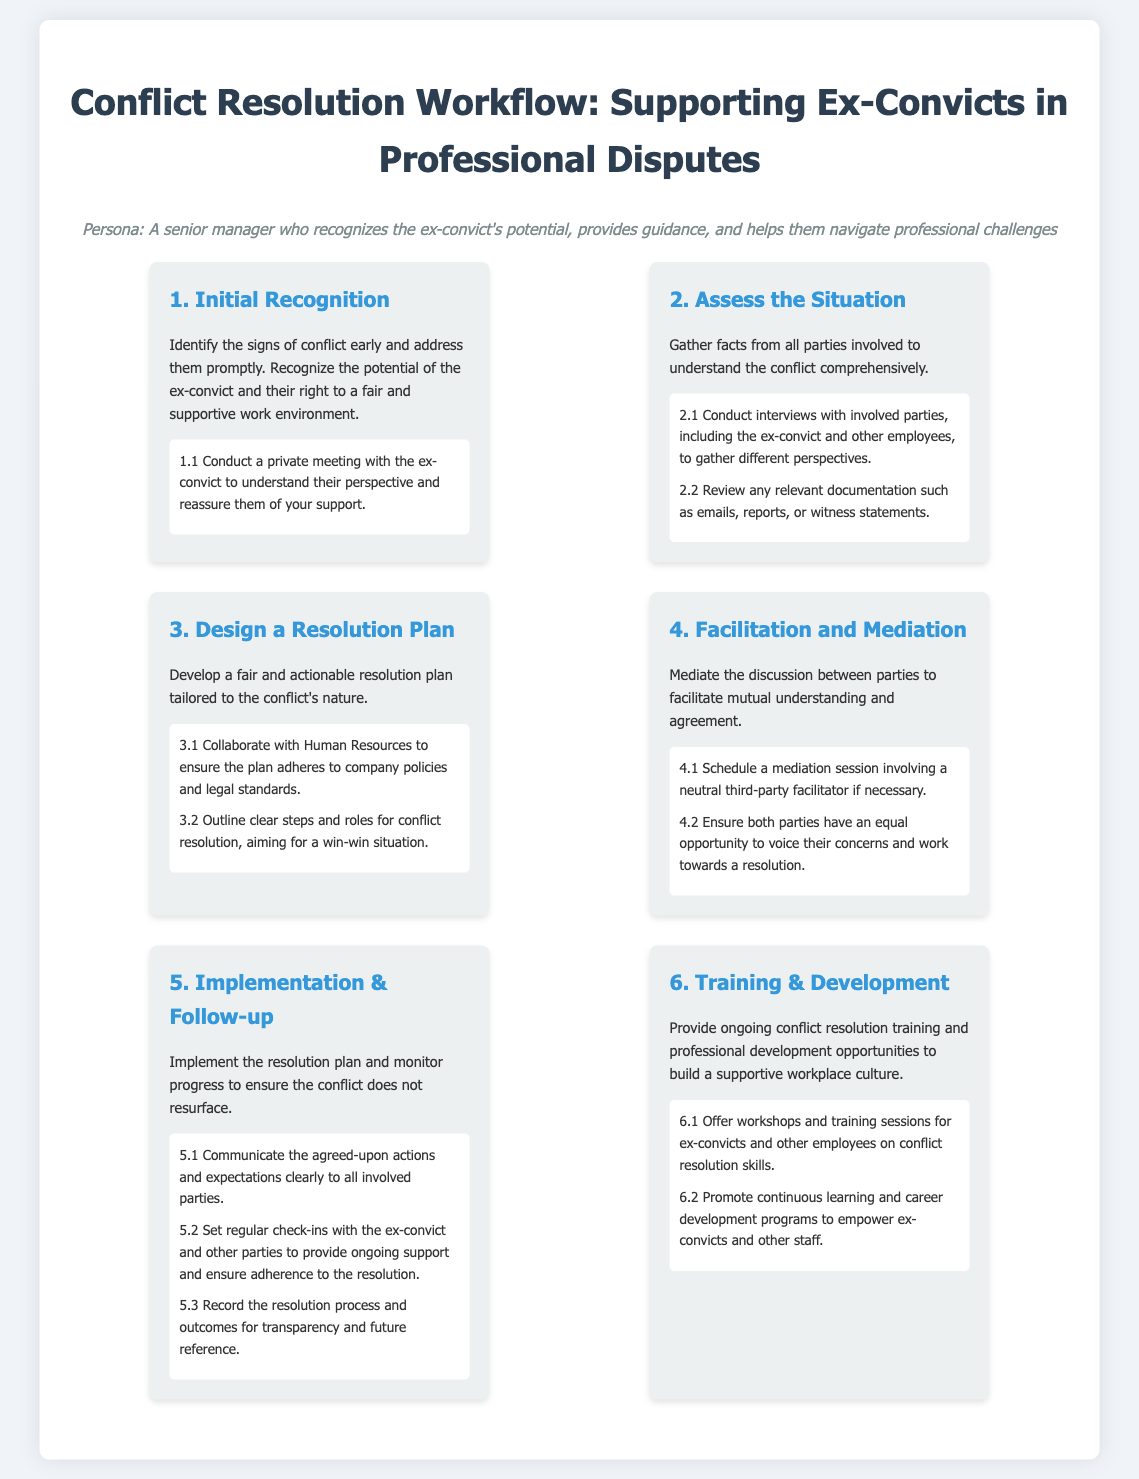What is the title of the document? The title of the document is displayed prominently at the top of the infographic.
Answer: Conflict Resolution Workflow: Supporting Ex-Convicts in Professional Disputes What is the first step in the conflict resolution workflow? The document outlines several steps in the workflow and specifies the first step.
Answer: Initial Recognition How many steps are in the conflict resolution workflow? The document lists a total of six distinct steps in the workflow.
Answer: 6 What is one action item in the "Assess the Situation" step? Each step includes action items, and one can be found in the "Assess the Situation" section.
Answer: Conduct interviews with involved parties, including the ex-convict and other employees, to gather different perspectives What is the main purpose of step 6? Each step serves a specific purpose, and step 6 is focused on a specific goal.
Answer: Provide ongoing conflict resolution training and professional development opportunities Which group should be involved in collaboratively designing the resolution plan? The document specifies collaboration with a key department during the resolution planning process.
Answer: Human Resources What is the recommended follow-up action after implementing the resolution plan? The steps include actions that should be taken after implementation, specifying the need for ongoing communication.
Answer: Set regular check-ins with the ex-convict and other parties to provide ongoing support What should be recorded for transparency according to step 5? The document mentions record-keeping as part of the follow-up to ensure clarity and accountability.
Answer: Record the resolution process and outcomes for transparency and future reference What color theme is primarily used in the document? The color scheme of the infographic can be observed throughout the design elements and text.
Answer: Blue and gray 